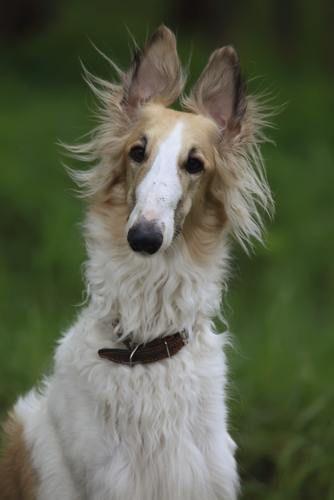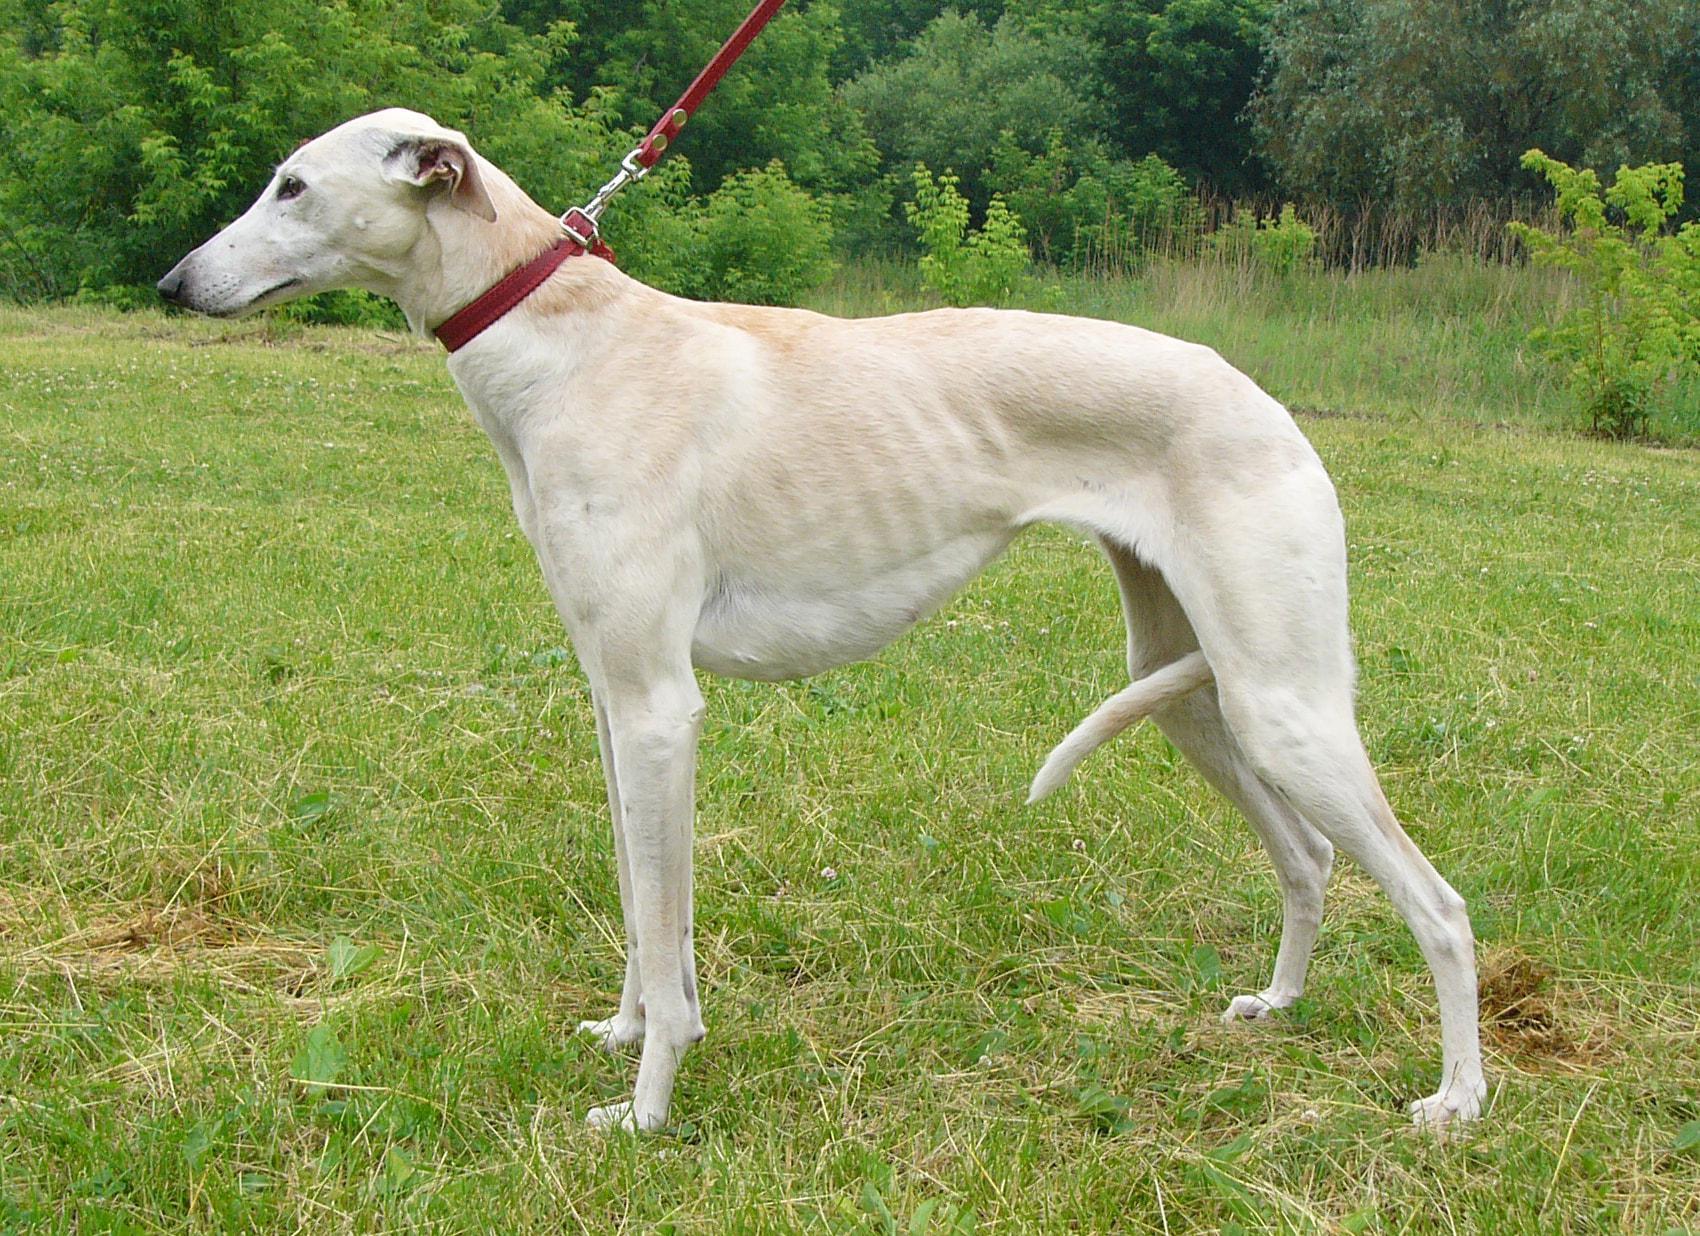The first image is the image on the left, the second image is the image on the right. Evaluate the accuracy of this statement regarding the images: "There is one dog in a grassy area in the image on the left.". Is it true? Answer yes or no. Yes. The first image is the image on the left, the second image is the image on the right. Evaluate the accuracy of this statement regarding the images: "An image shows a young animal of some type close to an adult hound with its body turned rightward.". Is it true? Answer yes or no. No. 